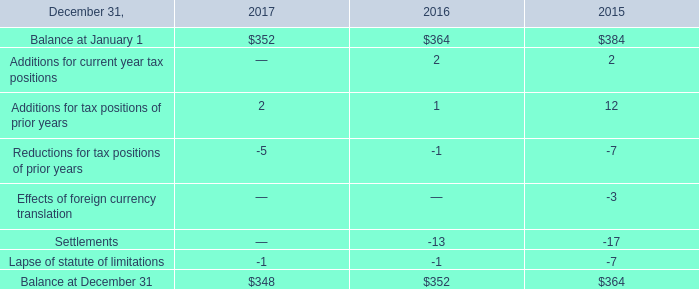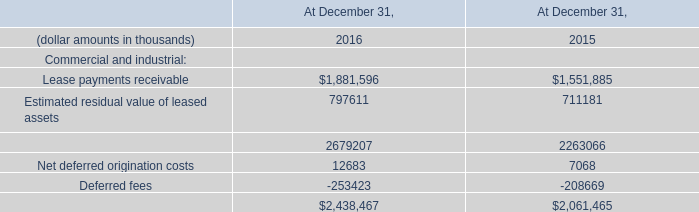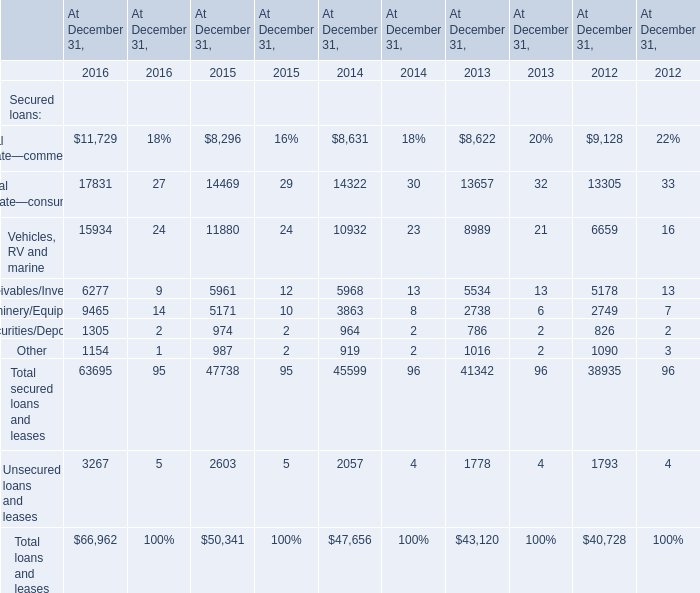What is the average amount of Net deferred origination costs of At December 31, 2016, and Real estate—consumer of At December 31, 2012 ? 
Computations: ((12683.0 + 13305.0) / 2)
Answer: 12994.0. 